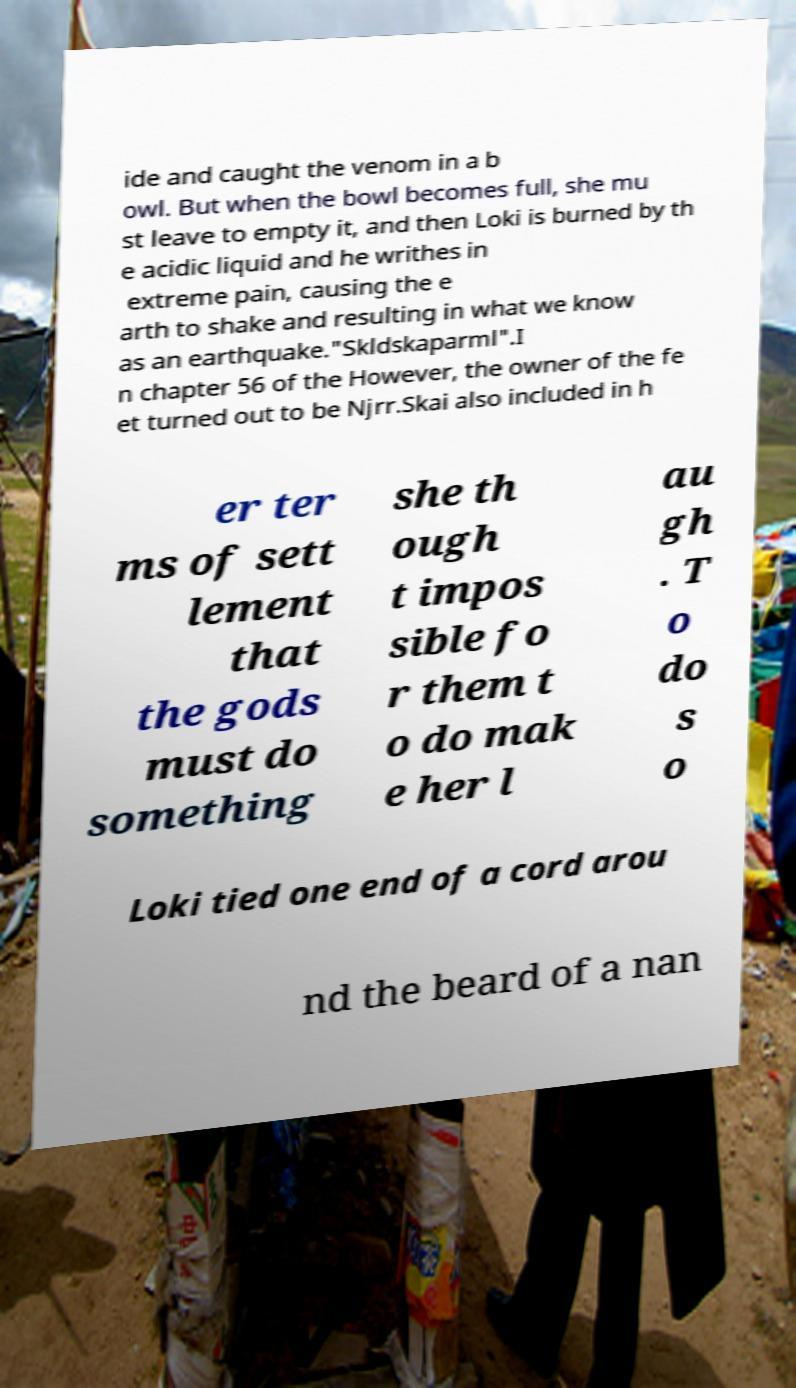Please read and relay the text visible in this image. What does it say? ide and caught the venom in a b owl. But when the bowl becomes full, she mu st leave to empty it, and then Loki is burned by th e acidic liquid and he writhes in extreme pain, causing the e arth to shake and resulting in what we know as an earthquake."Skldskaparml".I n chapter 56 of the However, the owner of the fe et turned out to be Njrr.Skai also included in h er ter ms of sett lement that the gods must do something she th ough t impos sible fo r them t o do mak e her l au gh . T o do s o Loki tied one end of a cord arou nd the beard of a nan 